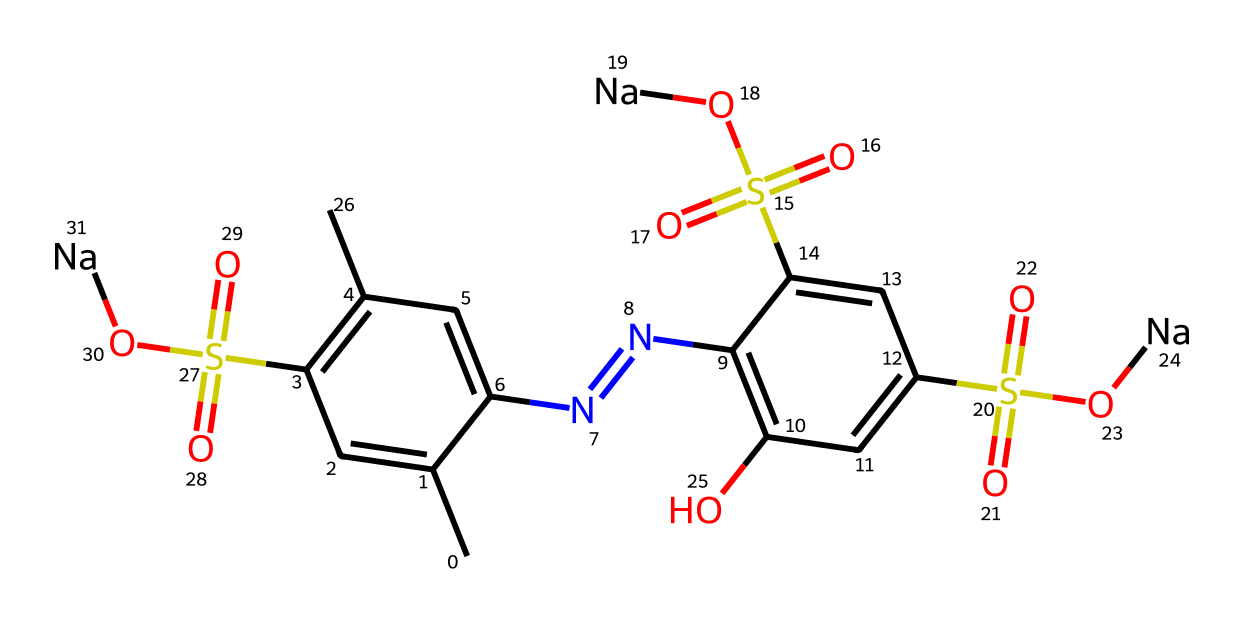what is the total number of carbon atoms in this structure? By analyzing the SMILES representation, we count the "C" symbols, which represent carbon atoms. There are a total of 15 carbon atoms in the structure.
Answer: 15 how many nitrogen atoms are present in this chemical? In the SMILES representation, we identify the "N" symbols that indicate nitrogen atoms. There are 2 nitrogen atoms present in the structure.
Answer: 2 what is the total number of sulfate groups in this compound? The sulfate groups are represented by the "S(=O)(=O)O" part of the SMILES. Upon counting, we find that there are 3 sulfate groups attached to the chemical structure.
Answer: 3 how many hydroxyl groups are present in this chemical? Hydroxyl groups are indicated by the "O" connected to "H" in structures, and in the SMILES, we can see 1 -OH group as part of the main structure, making it 1 hydroxyl group.
Answer: 1 which type of food colorant does this chemical structure represent? The presence of multiple aromatic rings and sulfonic acid groups, combined with the nitrogen atoms typically classifies it as an azo food colorant used widely in event catering.
Answer: azo colorant how many double bonds are present in the chemical structure? By interpreting the SMILES notation, we identify connections that indicate double bonds, particularly between carbon and nitrogen or carbon to carbon. Counting these, there are 6 double bonds in total.
Answer: 6 what is the significance of the sodium ions in this food additive? The sodium ions are represented as "[Na]" and usually indicate that the additive is in a soluble form, which enhances its functionality and usability in food applications, particularly in preserving or coloring food.
Answer: solubility 